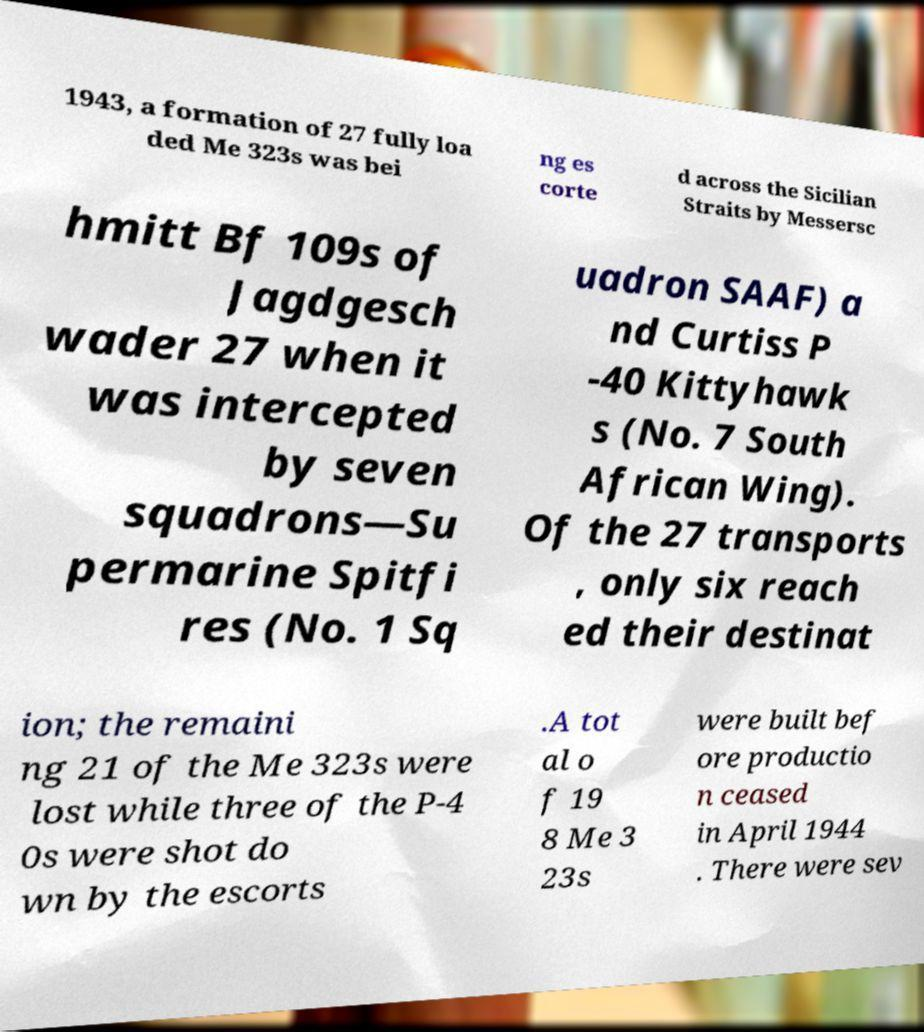For documentation purposes, I need the text within this image transcribed. Could you provide that? 1943, a formation of 27 fully loa ded Me 323s was bei ng es corte d across the Sicilian Straits by Messersc hmitt Bf 109s of Jagdgesch wader 27 when it was intercepted by seven squadrons—Su permarine Spitfi res (No. 1 Sq uadron SAAF) a nd Curtiss P -40 Kittyhawk s (No. 7 South African Wing). Of the 27 transports , only six reach ed their destinat ion; the remaini ng 21 of the Me 323s were lost while three of the P-4 0s were shot do wn by the escorts .A tot al o f 19 8 Me 3 23s were built bef ore productio n ceased in April 1944 . There were sev 